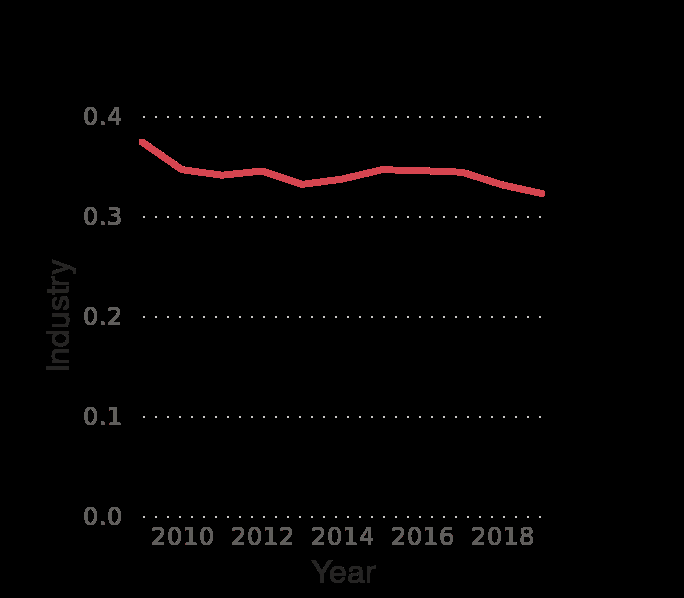<image>
How much was the decline in gross domestic production from 2009 to 2019? The decline in gross domestic production from 2009 to 2019 was less than 0.1. 